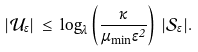Convert formula to latex. <formula><loc_0><loc_0><loc_500><loc_500>| \mathcal { U } _ { \epsilon } | \, \leq \, \log _ { \lambda } \left ( \frac { \kappa } { \mu _ { \min } \epsilon ^ { 2 } } \right ) \, | \mathcal { S } _ { \epsilon } | .</formula> 